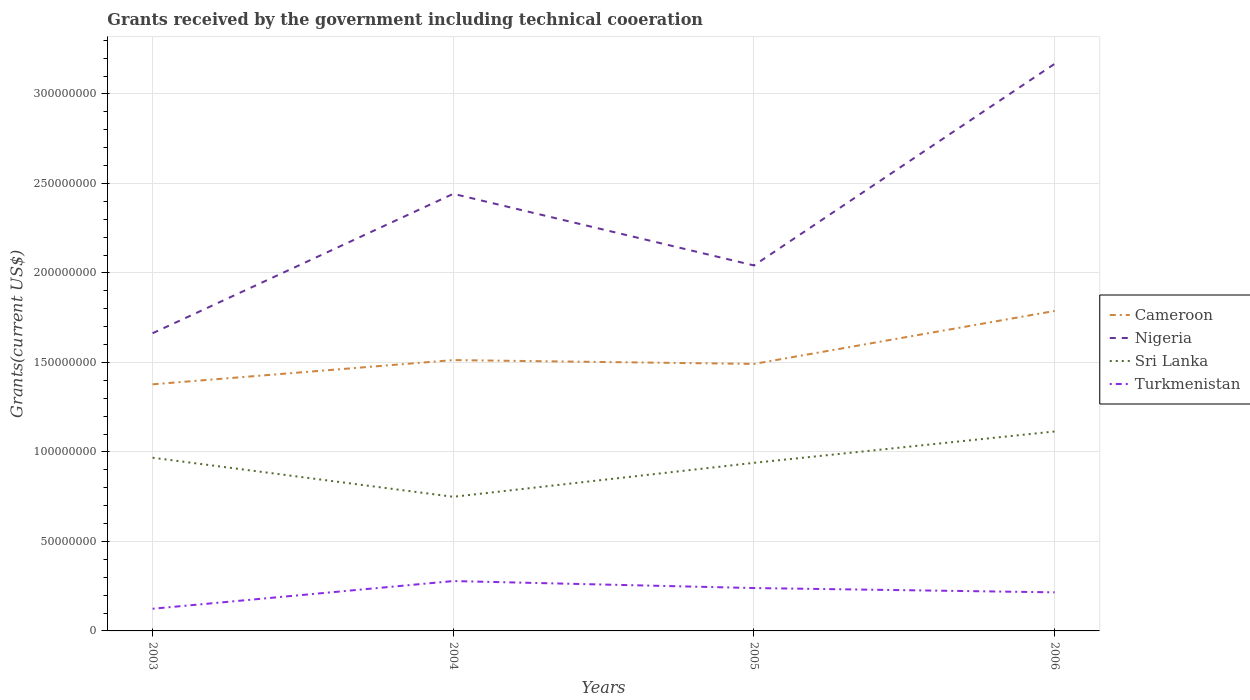How many different coloured lines are there?
Make the answer very short. 4. Is the number of lines equal to the number of legend labels?
Your answer should be compact. Yes. Across all years, what is the maximum total grants received by the government in Nigeria?
Your response must be concise. 1.66e+08. What is the total total grants received by the government in Cameroon in the graph?
Offer a terse response. -4.10e+07. What is the difference between the highest and the second highest total grants received by the government in Sri Lanka?
Give a very brief answer. 3.65e+07. What is the difference between the highest and the lowest total grants received by the government in Nigeria?
Provide a short and direct response. 2. How many lines are there?
Make the answer very short. 4. How many years are there in the graph?
Offer a terse response. 4. What is the difference between two consecutive major ticks on the Y-axis?
Offer a very short reply. 5.00e+07. Are the values on the major ticks of Y-axis written in scientific E-notation?
Ensure brevity in your answer.  No. Does the graph contain any zero values?
Provide a short and direct response. No. How are the legend labels stacked?
Offer a terse response. Vertical. What is the title of the graph?
Ensure brevity in your answer.  Grants received by the government including technical cooeration. Does "Equatorial Guinea" appear as one of the legend labels in the graph?
Give a very brief answer. No. What is the label or title of the X-axis?
Your answer should be compact. Years. What is the label or title of the Y-axis?
Provide a succinct answer. Grants(current US$). What is the Grants(current US$) of Cameroon in 2003?
Provide a short and direct response. 1.38e+08. What is the Grants(current US$) in Nigeria in 2003?
Your response must be concise. 1.66e+08. What is the Grants(current US$) in Sri Lanka in 2003?
Make the answer very short. 9.68e+07. What is the Grants(current US$) of Turkmenistan in 2003?
Provide a short and direct response. 1.24e+07. What is the Grants(current US$) of Cameroon in 2004?
Provide a succinct answer. 1.51e+08. What is the Grants(current US$) of Nigeria in 2004?
Your response must be concise. 2.44e+08. What is the Grants(current US$) in Sri Lanka in 2004?
Keep it short and to the point. 7.49e+07. What is the Grants(current US$) in Turkmenistan in 2004?
Ensure brevity in your answer.  2.79e+07. What is the Grants(current US$) in Cameroon in 2005?
Keep it short and to the point. 1.49e+08. What is the Grants(current US$) of Nigeria in 2005?
Your response must be concise. 2.04e+08. What is the Grants(current US$) of Sri Lanka in 2005?
Give a very brief answer. 9.39e+07. What is the Grants(current US$) in Turkmenistan in 2005?
Give a very brief answer. 2.40e+07. What is the Grants(current US$) in Cameroon in 2006?
Provide a short and direct response. 1.79e+08. What is the Grants(current US$) in Nigeria in 2006?
Provide a short and direct response. 3.17e+08. What is the Grants(current US$) in Sri Lanka in 2006?
Provide a short and direct response. 1.11e+08. What is the Grants(current US$) in Turkmenistan in 2006?
Your answer should be very brief. 2.16e+07. Across all years, what is the maximum Grants(current US$) of Cameroon?
Provide a short and direct response. 1.79e+08. Across all years, what is the maximum Grants(current US$) of Nigeria?
Your answer should be compact. 3.17e+08. Across all years, what is the maximum Grants(current US$) of Sri Lanka?
Provide a succinct answer. 1.11e+08. Across all years, what is the maximum Grants(current US$) of Turkmenistan?
Your response must be concise. 2.79e+07. Across all years, what is the minimum Grants(current US$) in Cameroon?
Provide a succinct answer. 1.38e+08. Across all years, what is the minimum Grants(current US$) in Nigeria?
Your answer should be compact. 1.66e+08. Across all years, what is the minimum Grants(current US$) of Sri Lanka?
Provide a short and direct response. 7.49e+07. Across all years, what is the minimum Grants(current US$) in Turkmenistan?
Offer a terse response. 1.24e+07. What is the total Grants(current US$) of Cameroon in the graph?
Ensure brevity in your answer.  6.17e+08. What is the total Grants(current US$) of Nigeria in the graph?
Your answer should be compact. 9.32e+08. What is the total Grants(current US$) of Sri Lanka in the graph?
Ensure brevity in your answer.  3.77e+08. What is the total Grants(current US$) in Turkmenistan in the graph?
Your answer should be very brief. 8.58e+07. What is the difference between the Grants(current US$) in Cameroon in 2003 and that in 2004?
Make the answer very short. -1.35e+07. What is the difference between the Grants(current US$) in Nigeria in 2003 and that in 2004?
Keep it short and to the point. -7.79e+07. What is the difference between the Grants(current US$) of Sri Lanka in 2003 and that in 2004?
Give a very brief answer. 2.18e+07. What is the difference between the Grants(current US$) of Turkmenistan in 2003 and that in 2004?
Provide a succinct answer. -1.55e+07. What is the difference between the Grants(current US$) of Cameroon in 2003 and that in 2005?
Ensure brevity in your answer.  -1.14e+07. What is the difference between the Grants(current US$) of Nigeria in 2003 and that in 2005?
Your answer should be compact. -3.79e+07. What is the difference between the Grants(current US$) of Sri Lanka in 2003 and that in 2005?
Give a very brief answer. 2.86e+06. What is the difference between the Grants(current US$) in Turkmenistan in 2003 and that in 2005?
Ensure brevity in your answer.  -1.16e+07. What is the difference between the Grants(current US$) in Cameroon in 2003 and that in 2006?
Your answer should be compact. -4.10e+07. What is the difference between the Grants(current US$) of Nigeria in 2003 and that in 2006?
Provide a short and direct response. -1.51e+08. What is the difference between the Grants(current US$) of Sri Lanka in 2003 and that in 2006?
Ensure brevity in your answer.  -1.47e+07. What is the difference between the Grants(current US$) of Turkmenistan in 2003 and that in 2006?
Keep it short and to the point. -9.17e+06. What is the difference between the Grants(current US$) in Cameroon in 2004 and that in 2005?
Offer a very short reply. 2.14e+06. What is the difference between the Grants(current US$) in Nigeria in 2004 and that in 2005?
Your answer should be very brief. 4.00e+07. What is the difference between the Grants(current US$) in Sri Lanka in 2004 and that in 2005?
Ensure brevity in your answer.  -1.90e+07. What is the difference between the Grants(current US$) of Turkmenistan in 2004 and that in 2005?
Make the answer very short. 3.90e+06. What is the difference between the Grants(current US$) in Cameroon in 2004 and that in 2006?
Give a very brief answer. -2.74e+07. What is the difference between the Grants(current US$) of Nigeria in 2004 and that in 2006?
Make the answer very short. -7.26e+07. What is the difference between the Grants(current US$) in Sri Lanka in 2004 and that in 2006?
Provide a short and direct response. -3.65e+07. What is the difference between the Grants(current US$) in Turkmenistan in 2004 and that in 2006?
Offer a terse response. 6.30e+06. What is the difference between the Grants(current US$) in Cameroon in 2005 and that in 2006?
Make the answer very short. -2.96e+07. What is the difference between the Grants(current US$) in Nigeria in 2005 and that in 2006?
Ensure brevity in your answer.  -1.13e+08. What is the difference between the Grants(current US$) in Sri Lanka in 2005 and that in 2006?
Provide a succinct answer. -1.75e+07. What is the difference between the Grants(current US$) of Turkmenistan in 2005 and that in 2006?
Your response must be concise. 2.40e+06. What is the difference between the Grants(current US$) in Cameroon in 2003 and the Grants(current US$) in Nigeria in 2004?
Give a very brief answer. -1.06e+08. What is the difference between the Grants(current US$) of Cameroon in 2003 and the Grants(current US$) of Sri Lanka in 2004?
Give a very brief answer. 6.28e+07. What is the difference between the Grants(current US$) in Cameroon in 2003 and the Grants(current US$) in Turkmenistan in 2004?
Your response must be concise. 1.10e+08. What is the difference between the Grants(current US$) in Nigeria in 2003 and the Grants(current US$) in Sri Lanka in 2004?
Offer a very short reply. 9.14e+07. What is the difference between the Grants(current US$) of Nigeria in 2003 and the Grants(current US$) of Turkmenistan in 2004?
Ensure brevity in your answer.  1.38e+08. What is the difference between the Grants(current US$) of Sri Lanka in 2003 and the Grants(current US$) of Turkmenistan in 2004?
Keep it short and to the point. 6.89e+07. What is the difference between the Grants(current US$) of Cameroon in 2003 and the Grants(current US$) of Nigeria in 2005?
Provide a short and direct response. -6.64e+07. What is the difference between the Grants(current US$) of Cameroon in 2003 and the Grants(current US$) of Sri Lanka in 2005?
Provide a succinct answer. 4.39e+07. What is the difference between the Grants(current US$) in Cameroon in 2003 and the Grants(current US$) in Turkmenistan in 2005?
Keep it short and to the point. 1.14e+08. What is the difference between the Grants(current US$) in Nigeria in 2003 and the Grants(current US$) in Sri Lanka in 2005?
Provide a succinct answer. 7.24e+07. What is the difference between the Grants(current US$) of Nigeria in 2003 and the Grants(current US$) of Turkmenistan in 2005?
Provide a succinct answer. 1.42e+08. What is the difference between the Grants(current US$) in Sri Lanka in 2003 and the Grants(current US$) in Turkmenistan in 2005?
Give a very brief answer. 7.28e+07. What is the difference between the Grants(current US$) of Cameroon in 2003 and the Grants(current US$) of Nigeria in 2006?
Provide a succinct answer. -1.79e+08. What is the difference between the Grants(current US$) in Cameroon in 2003 and the Grants(current US$) in Sri Lanka in 2006?
Your answer should be compact. 2.63e+07. What is the difference between the Grants(current US$) in Cameroon in 2003 and the Grants(current US$) in Turkmenistan in 2006?
Give a very brief answer. 1.16e+08. What is the difference between the Grants(current US$) in Nigeria in 2003 and the Grants(current US$) in Sri Lanka in 2006?
Your answer should be very brief. 5.49e+07. What is the difference between the Grants(current US$) of Nigeria in 2003 and the Grants(current US$) of Turkmenistan in 2006?
Provide a succinct answer. 1.45e+08. What is the difference between the Grants(current US$) in Sri Lanka in 2003 and the Grants(current US$) in Turkmenistan in 2006?
Provide a succinct answer. 7.52e+07. What is the difference between the Grants(current US$) in Cameroon in 2004 and the Grants(current US$) in Nigeria in 2005?
Your response must be concise. -5.29e+07. What is the difference between the Grants(current US$) of Cameroon in 2004 and the Grants(current US$) of Sri Lanka in 2005?
Provide a succinct answer. 5.74e+07. What is the difference between the Grants(current US$) of Cameroon in 2004 and the Grants(current US$) of Turkmenistan in 2005?
Provide a succinct answer. 1.27e+08. What is the difference between the Grants(current US$) of Nigeria in 2004 and the Grants(current US$) of Sri Lanka in 2005?
Your answer should be very brief. 1.50e+08. What is the difference between the Grants(current US$) in Nigeria in 2004 and the Grants(current US$) in Turkmenistan in 2005?
Offer a terse response. 2.20e+08. What is the difference between the Grants(current US$) in Sri Lanka in 2004 and the Grants(current US$) in Turkmenistan in 2005?
Keep it short and to the point. 5.10e+07. What is the difference between the Grants(current US$) of Cameroon in 2004 and the Grants(current US$) of Nigeria in 2006?
Keep it short and to the point. -1.66e+08. What is the difference between the Grants(current US$) of Cameroon in 2004 and the Grants(current US$) of Sri Lanka in 2006?
Your response must be concise. 3.99e+07. What is the difference between the Grants(current US$) in Cameroon in 2004 and the Grants(current US$) in Turkmenistan in 2006?
Provide a short and direct response. 1.30e+08. What is the difference between the Grants(current US$) in Nigeria in 2004 and the Grants(current US$) in Sri Lanka in 2006?
Make the answer very short. 1.33e+08. What is the difference between the Grants(current US$) in Nigeria in 2004 and the Grants(current US$) in Turkmenistan in 2006?
Ensure brevity in your answer.  2.23e+08. What is the difference between the Grants(current US$) of Sri Lanka in 2004 and the Grants(current US$) of Turkmenistan in 2006?
Your answer should be very brief. 5.34e+07. What is the difference between the Grants(current US$) in Cameroon in 2005 and the Grants(current US$) in Nigeria in 2006?
Your response must be concise. -1.68e+08. What is the difference between the Grants(current US$) of Cameroon in 2005 and the Grants(current US$) of Sri Lanka in 2006?
Provide a short and direct response. 3.77e+07. What is the difference between the Grants(current US$) in Cameroon in 2005 and the Grants(current US$) in Turkmenistan in 2006?
Provide a short and direct response. 1.28e+08. What is the difference between the Grants(current US$) of Nigeria in 2005 and the Grants(current US$) of Sri Lanka in 2006?
Your answer should be compact. 9.28e+07. What is the difference between the Grants(current US$) in Nigeria in 2005 and the Grants(current US$) in Turkmenistan in 2006?
Provide a succinct answer. 1.83e+08. What is the difference between the Grants(current US$) of Sri Lanka in 2005 and the Grants(current US$) of Turkmenistan in 2006?
Your response must be concise. 7.24e+07. What is the average Grants(current US$) in Cameroon per year?
Your answer should be very brief. 1.54e+08. What is the average Grants(current US$) of Nigeria per year?
Offer a terse response. 2.33e+08. What is the average Grants(current US$) in Sri Lanka per year?
Ensure brevity in your answer.  9.43e+07. What is the average Grants(current US$) in Turkmenistan per year?
Your answer should be compact. 2.14e+07. In the year 2003, what is the difference between the Grants(current US$) of Cameroon and Grants(current US$) of Nigeria?
Make the answer very short. -2.85e+07. In the year 2003, what is the difference between the Grants(current US$) in Cameroon and Grants(current US$) in Sri Lanka?
Give a very brief answer. 4.10e+07. In the year 2003, what is the difference between the Grants(current US$) of Cameroon and Grants(current US$) of Turkmenistan?
Your answer should be compact. 1.25e+08. In the year 2003, what is the difference between the Grants(current US$) in Nigeria and Grants(current US$) in Sri Lanka?
Your answer should be compact. 6.96e+07. In the year 2003, what is the difference between the Grants(current US$) in Nigeria and Grants(current US$) in Turkmenistan?
Your response must be concise. 1.54e+08. In the year 2003, what is the difference between the Grants(current US$) of Sri Lanka and Grants(current US$) of Turkmenistan?
Make the answer very short. 8.44e+07. In the year 2004, what is the difference between the Grants(current US$) of Cameroon and Grants(current US$) of Nigeria?
Ensure brevity in your answer.  -9.29e+07. In the year 2004, what is the difference between the Grants(current US$) in Cameroon and Grants(current US$) in Sri Lanka?
Make the answer very short. 7.64e+07. In the year 2004, what is the difference between the Grants(current US$) in Cameroon and Grants(current US$) in Turkmenistan?
Provide a succinct answer. 1.23e+08. In the year 2004, what is the difference between the Grants(current US$) of Nigeria and Grants(current US$) of Sri Lanka?
Offer a very short reply. 1.69e+08. In the year 2004, what is the difference between the Grants(current US$) of Nigeria and Grants(current US$) of Turkmenistan?
Your response must be concise. 2.16e+08. In the year 2004, what is the difference between the Grants(current US$) of Sri Lanka and Grants(current US$) of Turkmenistan?
Keep it short and to the point. 4.71e+07. In the year 2005, what is the difference between the Grants(current US$) of Cameroon and Grants(current US$) of Nigeria?
Offer a terse response. -5.50e+07. In the year 2005, what is the difference between the Grants(current US$) in Cameroon and Grants(current US$) in Sri Lanka?
Your answer should be very brief. 5.53e+07. In the year 2005, what is the difference between the Grants(current US$) of Cameroon and Grants(current US$) of Turkmenistan?
Make the answer very short. 1.25e+08. In the year 2005, what is the difference between the Grants(current US$) of Nigeria and Grants(current US$) of Sri Lanka?
Keep it short and to the point. 1.10e+08. In the year 2005, what is the difference between the Grants(current US$) in Nigeria and Grants(current US$) in Turkmenistan?
Provide a succinct answer. 1.80e+08. In the year 2005, what is the difference between the Grants(current US$) in Sri Lanka and Grants(current US$) in Turkmenistan?
Your answer should be compact. 7.00e+07. In the year 2006, what is the difference between the Grants(current US$) of Cameroon and Grants(current US$) of Nigeria?
Provide a succinct answer. -1.38e+08. In the year 2006, what is the difference between the Grants(current US$) in Cameroon and Grants(current US$) in Sri Lanka?
Offer a very short reply. 6.73e+07. In the year 2006, what is the difference between the Grants(current US$) in Cameroon and Grants(current US$) in Turkmenistan?
Provide a succinct answer. 1.57e+08. In the year 2006, what is the difference between the Grants(current US$) in Nigeria and Grants(current US$) in Sri Lanka?
Keep it short and to the point. 2.05e+08. In the year 2006, what is the difference between the Grants(current US$) in Nigeria and Grants(current US$) in Turkmenistan?
Your answer should be very brief. 2.95e+08. In the year 2006, what is the difference between the Grants(current US$) in Sri Lanka and Grants(current US$) in Turkmenistan?
Your answer should be very brief. 8.99e+07. What is the ratio of the Grants(current US$) in Cameroon in 2003 to that in 2004?
Ensure brevity in your answer.  0.91. What is the ratio of the Grants(current US$) in Nigeria in 2003 to that in 2004?
Offer a very short reply. 0.68. What is the ratio of the Grants(current US$) of Sri Lanka in 2003 to that in 2004?
Your answer should be compact. 1.29. What is the ratio of the Grants(current US$) in Turkmenistan in 2003 to that in 2004?
Keep it short and to the point. 0.44. What is the ratio of the Grants(current US$) of Cameroon in 2003 to that in 2005?
Ensure brevity in your answer.  0.92. What is the ratio of the Grants(current US$) of Nigeria in 2003 to that in 2005?
Give a very brief answer. 0.81. What is the ratio of the Grants(current US$) of Sri Lanka in 2003 to that in 2005?
Offer a very short reply. 1.03. What is the ratio of the Grants(current US$) in Turkmenistan in 2003 to that in 2005?
Provide a succinct answer. 0.52. What is the ratio of the Grants(current US$) of Cameroon in 2003 to that in 2006?
Your answer should be very brief. 0.77. What is the ratio of the Grants(current US$) of Nigeria in 2003 to that in 2006?
Ensure brevity in your answer.  0.52. What is the ratio of the Grants(current US$) in Sri Lanka in 2003 to that in 2006?
Give a very brief answer. 0.87. What is the ratio of the Grants(current US$) of Turkmenistan in 2003 to that in 2006?
Keep it short and to the point. 0.57. What is the ratio of the Grants(current US$) in Cameroon in 2004 to that in 2005?
Provide a short and direct response. 1.01. What is the ratio of the Grants(current US$) in Nigeria in 2004 to that in 2005?
Give a very brief answer. 1.2. What is the ratio of the Grants(current US$) in Sri Lanka in 2004 to that in 2005?
Provide a short and direct response. 0.8. What is the ratio of the Grants(current US$) in Turkmenistan in 2004 to that in 2005?
Make the answer very short. 1.16. What is the ratio of the Grants(current US$) in Cameroon in 2004 to that in 2006?
Keep it short and to the point. 0.85. What is the ratio of the Grants(current US$) in Nigeria in 2004 to that in 2006?
Offer a very short reply. 0.77. What is the ratio of the Grants(current US$) of Sri Lanka in 2004 to that in 2006?
Your response must be concise. 0.67. What is the ratio of the Grants(current US$) in Turkmenistan in 2004 to that in 2006?
Give a very brief answer. 1.29. What is the ratio of the Grants(current US$) in Cameroon in 2005 to that in 2006?
Keep it short and to the point. 0.83. What is the ratio of the Grants(current US$) of Nigeria in 2005 to that in 2006?
Ensure brevity in your answer.  0.64. What is the ratio of the Grants(current US$) of Sri Lanka in 2005 to that in 2006?
Make the answer very short. 0.84. What is the ratio of the Grants(current US$) in Turkmenistan in 2005 to that in 2006?
Make the answer very short. 1.11. What is the difference between the highest and the second highest Grants(current US$) of Cameroon?
Offer a very short reply. 2.74e+07. What is the difference between the highest and the second highest Grants(current US$) of Nigeria?
Offer a very short reply. 7.26e+07. What is the difference between the highest and the second highest Grants(current US$) in Sri Lanka?
Your answer should be compact. 1.47e+07. What is the difference between the highest and the second highest Grants(current US$) in Turkmenistan?
Provide a short and direct response. 3.90e+06. What is the difference between the highest and the lowest Grants(current US$) of Cameroon?
Provide a succinct answer. 4.10e+07. What is the difference between the highest and the lowest Grants(current US$) in Nigeria?
Provide a succinct answer. 1.51e+08. What is the difference between the highest and the lowest Grants(current US$) in Sri Lanka?
Make the answer very short. 3.65e+07. What is the difference between the highest and the lowest Grants(current US$) in Turkmenistan?
Your answer should be compact. 1.55e+07. 